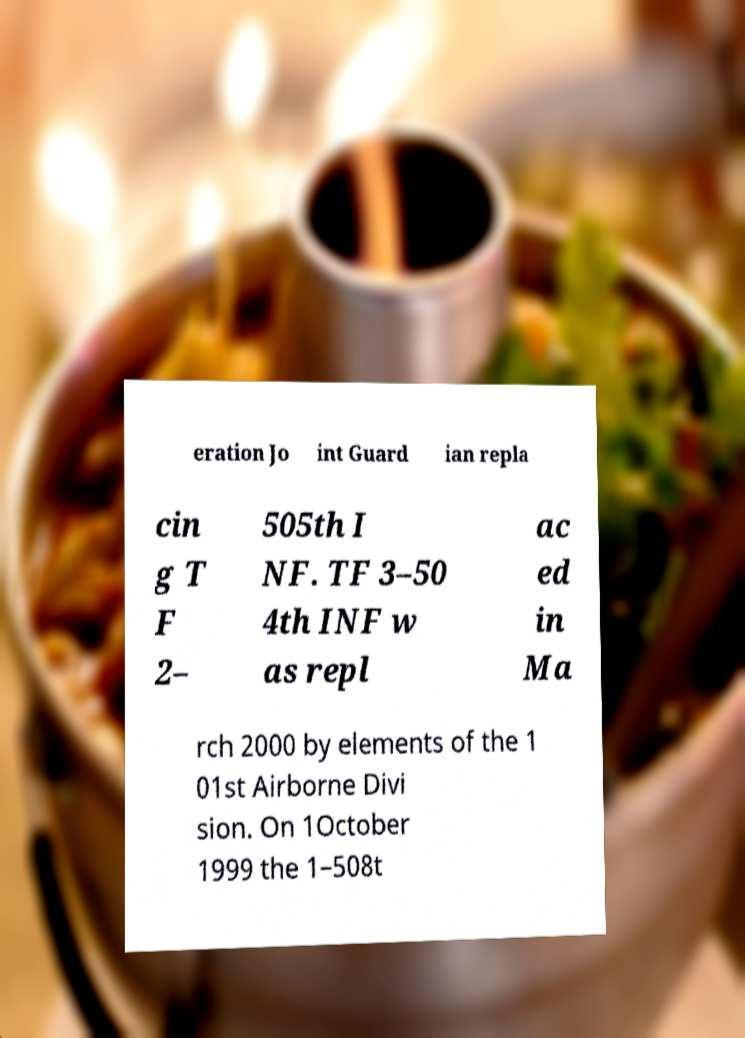Could you extract and type out the text from this image? eration Jo int Guard ian repla cin g T F 2– 505th I NF. TF 3–50 4th INF w as repl ac ed in Ma rch 2000 by elements of the 1 01st Airborne Divi sion. On 1October 1999 the 1–508t 